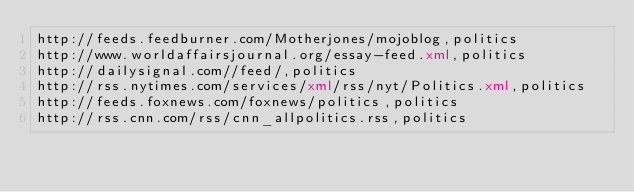Convert code to text. <code><loc_0><loc_0><loc_500><loc_500><_XML_>http://feeds.feedburner.com/Motherjones/mojoblog,politics
http://www.worldaffairsjournal.org/essay-feed.xml,politics
http://dailysignal.com//feed/,politics
http://rss.nytimes.com/services/xml/rss/nyt/Politics.xml,politics
http://feeds.foxnews.com/foxnews/politics,politics
http://rss.cnn.com/rss/cnn_allpolitics.rss,politics</code> 